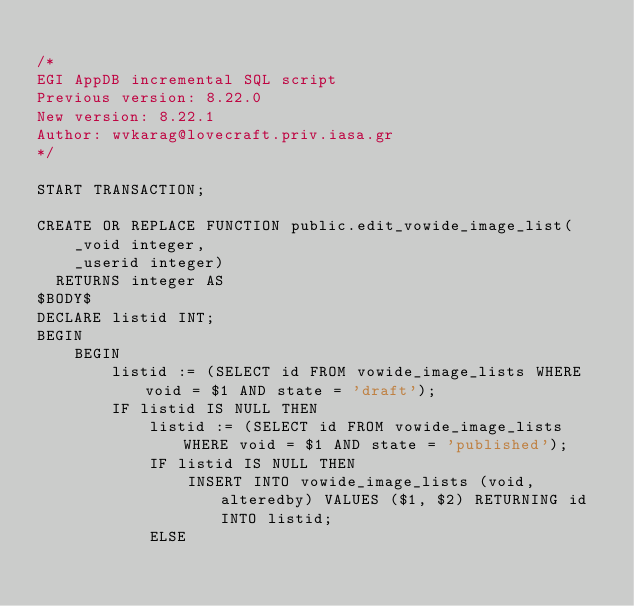<code> <loc_0><loc_0><loc_500><loc_500><_SQL_>
/* 
EGI AppDB incremental SQL script
Previous version: 8.22.0
New version: 8.22.1
Author: wvkarag@lovecraft.priv.iasa.gr
*/

START TRANSACTION;

CREATE OR REPLACE FUNCTION public.edit_vowide_image_list(
    _void integer,
    _userid integer)
  RETURNS integer AS
$BODY$
DECLARE listid INT;
BEGIN
	BEGIN
		listid := (SELECT id FROM vowide_image_lists WHERE void = $1 AND state = 'draft');
		IF listid IS NULL THEN
			listid := (SELECT id FROM vowide_image_lists WHERE void = $1 AND state = 'published');
			IF listid IS NULL THEN
				INSERT INTO vowide_image_lists (void, alteredby) VALUES ($1, $2) RETURNING id INTO listid;
			ELSE</code> 